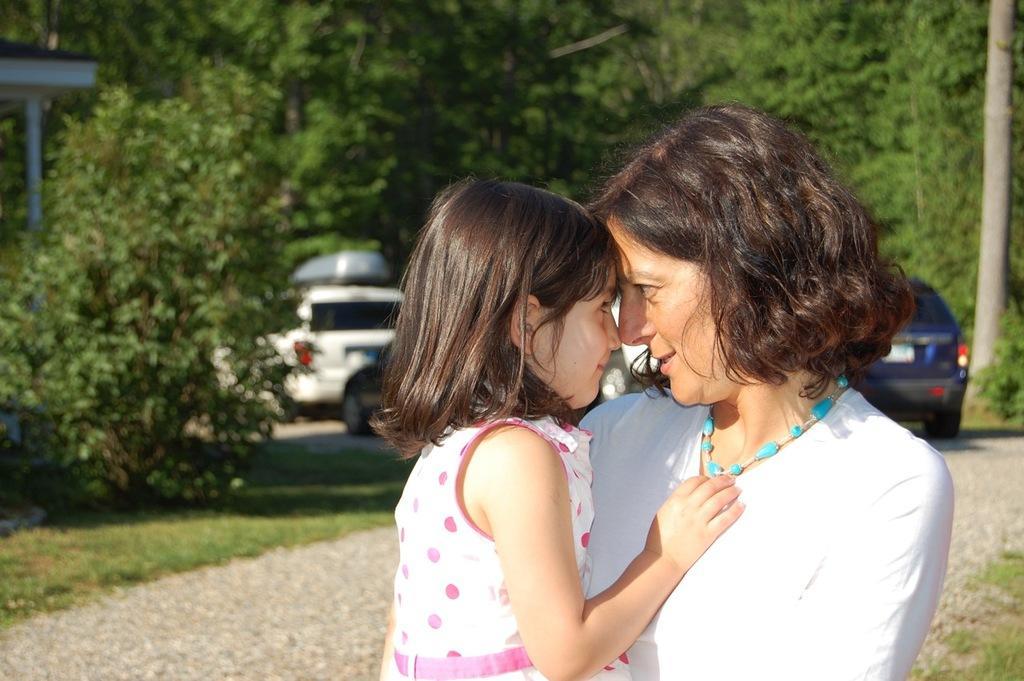In one or two sentences, can you explain what this image depicts? In the center of the image, we can see a lady holding a kid and in the background, there are vehicles on the road and we can see trees and a shed. 